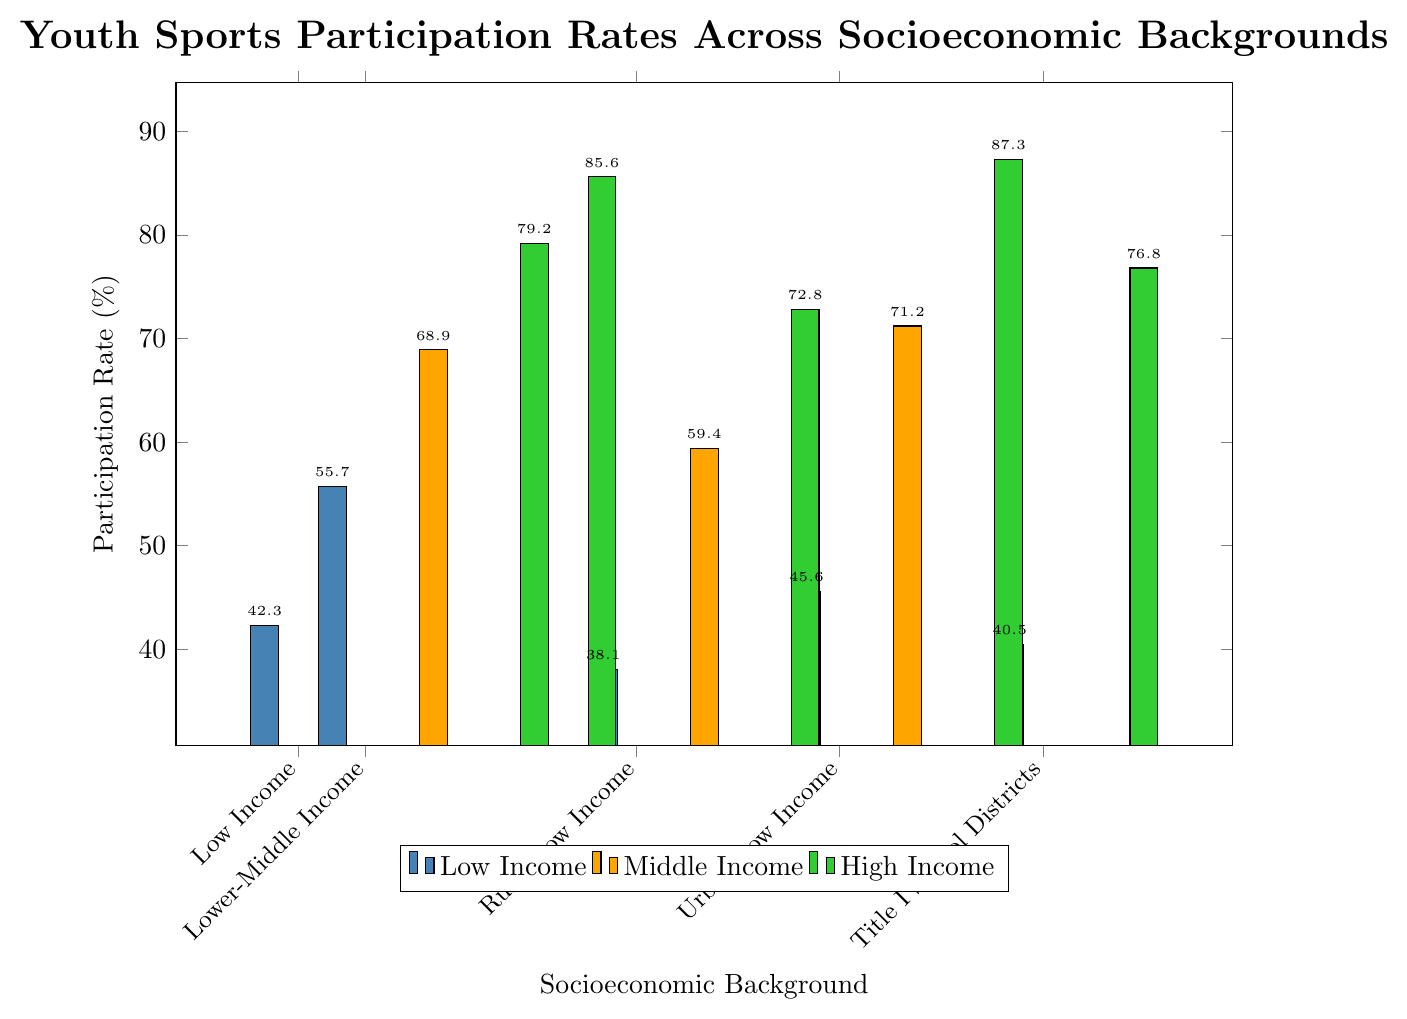What is the participation rate for Title I School Districts? The participation rate for Title I School Districts is directly shown on the bar chart as one of the data points. By looking at the corresponding bar, the rate is 40.5%.
Answer: 40.5% How does the participation rate of Upper-Middle Income compare to Rural High Income? To compare, we observe the heights of the bars corresponding to these categories. Upper-Middle Income has a participation rate of 79.2%, while Rural High Income has 72.8%.
Answer: Upper-Middle Income is higher What is the difference in participation rates between Urban High Income and Low Income groups? To find the difference, subtract the participation rate of Low Income (42.3%) from the participation rate of Urban High Income (87.3%): 87.3% - 42.3% = 45%.
Answer: 45% What color is used to represent the Low Income category in the chart? By observing the legend and the color of the corresponding bars, Low Income is denoted by the color blue.
Answer: blue What is the average participation rate of all Rural areas combined (Rural Low Income, Rural Middle Income, and Rural High Income)? Calculate the average by summing the participation rates of the rural categories and dividing by the number of categories: (38.1% + 59.4% + 72.8%) / 3 = 56.77%.
Answer: 56.77% Which socioeconomic background has the highest participation rate, and what is that rate? By examining the heights of all the bars, Urban High Income has the highest participation rate, which is 87.3%.
Answer: Urban High Income, 87.3% Between Urban Low Income and Rural Low Income, which has a higher participation rate, and by how much? Compare the bar heights: Urban Low Income (45.6%) is higher than Rural Low Income (38.1%). The difference is 45.6% - 38.1% = 7.5%.
Answer: Urban Low Income, 7.5% What is the total participation rate if combining all High Income categories (High Income, Rural High Income, Urban High Income, and Non-Title I School Districts)? Add the participation rates of the High Income categories: 85.6% + 72.8% + 87.3% + 76.8% = 322.5%.
Answer: 322.5% Compare participation rates between Title I School Districts and Non-Title I School Districts, which has a lower rate and by how much? Title I School Districts have a participation rate of 40.5%, while Non-Title I School Districts have 76.8%. The difference is 76.8% - 40.5% = 36.3%.
Answer: Title I School Districts, 36.3% 